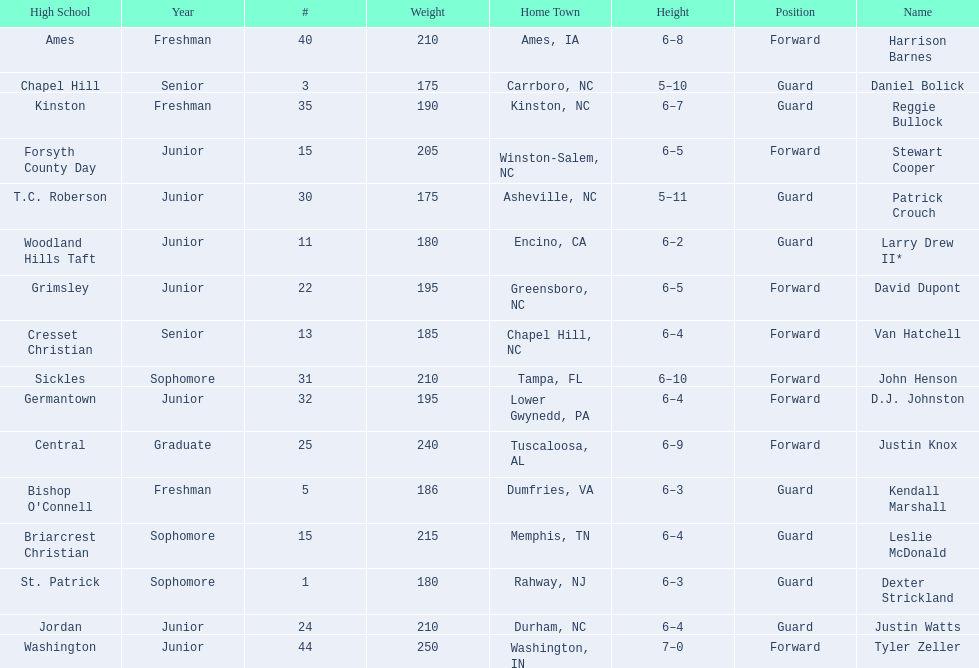Could you parse the entire table? {'header': ['High School', 'Year', '#', 'Weight', 'Home Town', 'Height', 'Position', 'Name'], 'rows': [['Ames', 'Freshman', '40', '210', 'Ames, IA', '6–8', 'Forward', 'Harrison Barnes'], ['Chapel Hill', 'Senior', '3', '175', 'Carrboro, NC', '5–10', 'Guard', 'Daniel Bolick'], ['Kinston', 'Freshman', '35', '190', 'Kinston, NC', '6–7', 'Guard', 'Reggie Bullock'], ['Forsyth County Day', 'Junior', '15', '205', 'Winston-Salem, NC', '6–5', 'Forward', 'Stewart Cooper'], ['T.C. Roberson', 'Junior', '30', '175', 'Asheville, NC', '5–11', 'Guard', 'Patrick Crouch'], ['Woodland Hills Taft', 'Junior', '11', '180', 'Encino, CA', '6–2', 'Guard', 'Larry Drew II*'], ['Grimsley', 'Junior', '22', '195', 'Greensboro, NC', '6–5', 'Forward', 'David Dupont'], ['Cresset Christian', 'Senior', '13', '185', 'Chapel Hill, NC', '6–4', 'Forward', 'Van Hatchell'], ['Sickles', 'Sophomore', '31', '210', 'Tampa, FL', '6–10', 'Forward', 'John Henson'], ['Germantown', 'Junior', '32', '195', 'Lower Gwynedd, PA', '6–4', 'Forward', 'D.J. Johnston'], ['Central', 'Graduate', '25', '240', 'Tuscaloosa, AL', '6–9', 'Forward', 'Justin Knox'], ["Bishop O'Connell", 'Freshman', '5', '186', 'Dumfries, VA', '6–3', 'Guard', 'Kendall Marshall'], ['Briarcrest Christian', 'Sophomore', '15', '215', 'Memphis, TN', '6–4', 'Guard', 'Leslie McDonald'], ['St. Patrick', 'Sophomore', '1', '180', 'Rahway, NJ', '6–3', 'Guard', 'Dexter Strickland'], ['Jordan', 'Junior', '24', '210', 'Durham, NC', '6–4', 'Guard', 'Justin Watts'], ['Washington', 'Junior', '44', '250', 'Washington, IN', '7–0', 'Forward', 'Tyler Zeller']]} Names of players who were exactly 6 feet, 4 inches tall, but did not weight over 200 pounds Van Hatchell, D.J. Johnston. 